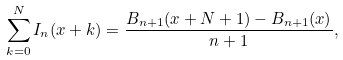Convert formula to latex. <formula><loc_0><loc_0><loc_500><loc_500>\sum _ { k = 0 } ^ { N } I _ { n } ( x + k ) = \frac { B _ { n + 1 } ( x + N + 1 ) - B _ { n + 1 } ( x ) } { n + 1 } ,</formula> 